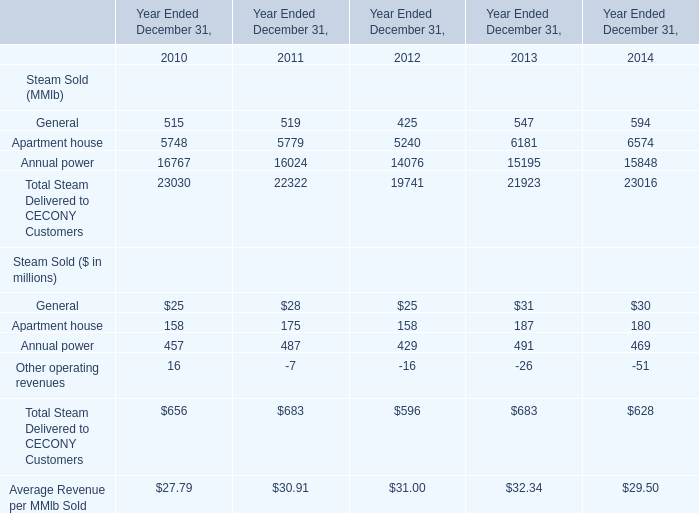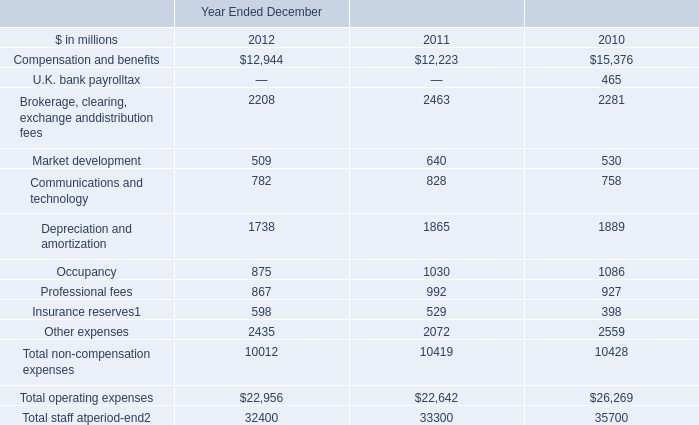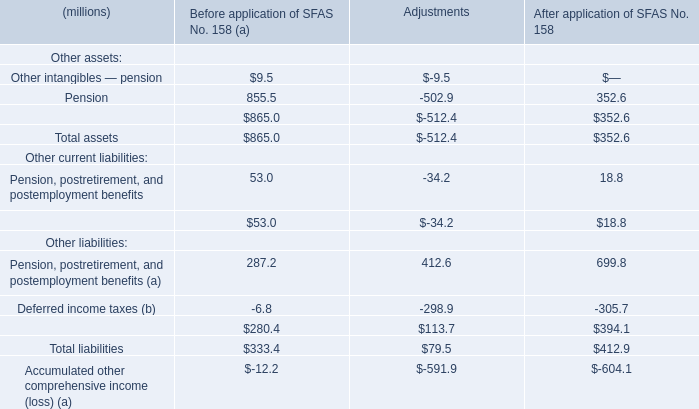What's the sum of Apartment house of Year Ended December 31, 2012, Compensation and benefits of Year Ended December 2010, and Depreciation and amortization of Year Ended December 2012 ? 
Computations: ((5240.0 + 15376.0) + 1738.0)
Answer: 22354.0. 